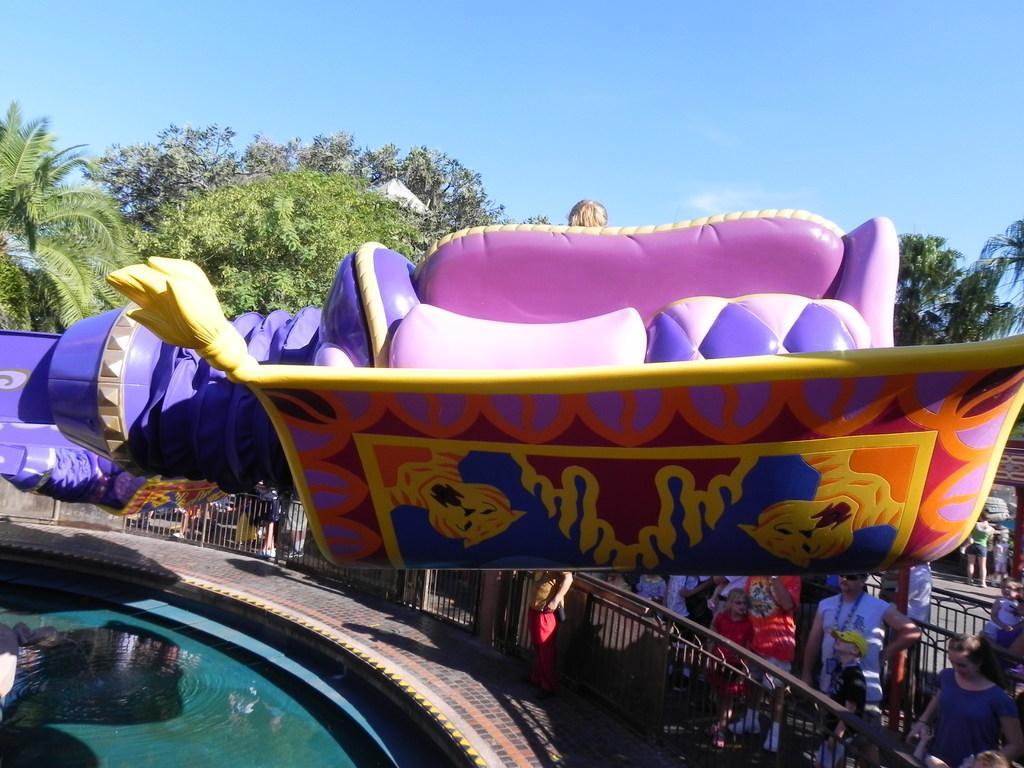Please provide a concise description of this image. In this picture there is a person sitting on the seat and there is a game. At the back there are group of people standing behind the railing and there is a person standing in front of the railing. At the bottom there is water and there is a pavement. At the back there are trees. At the top there is sky. 